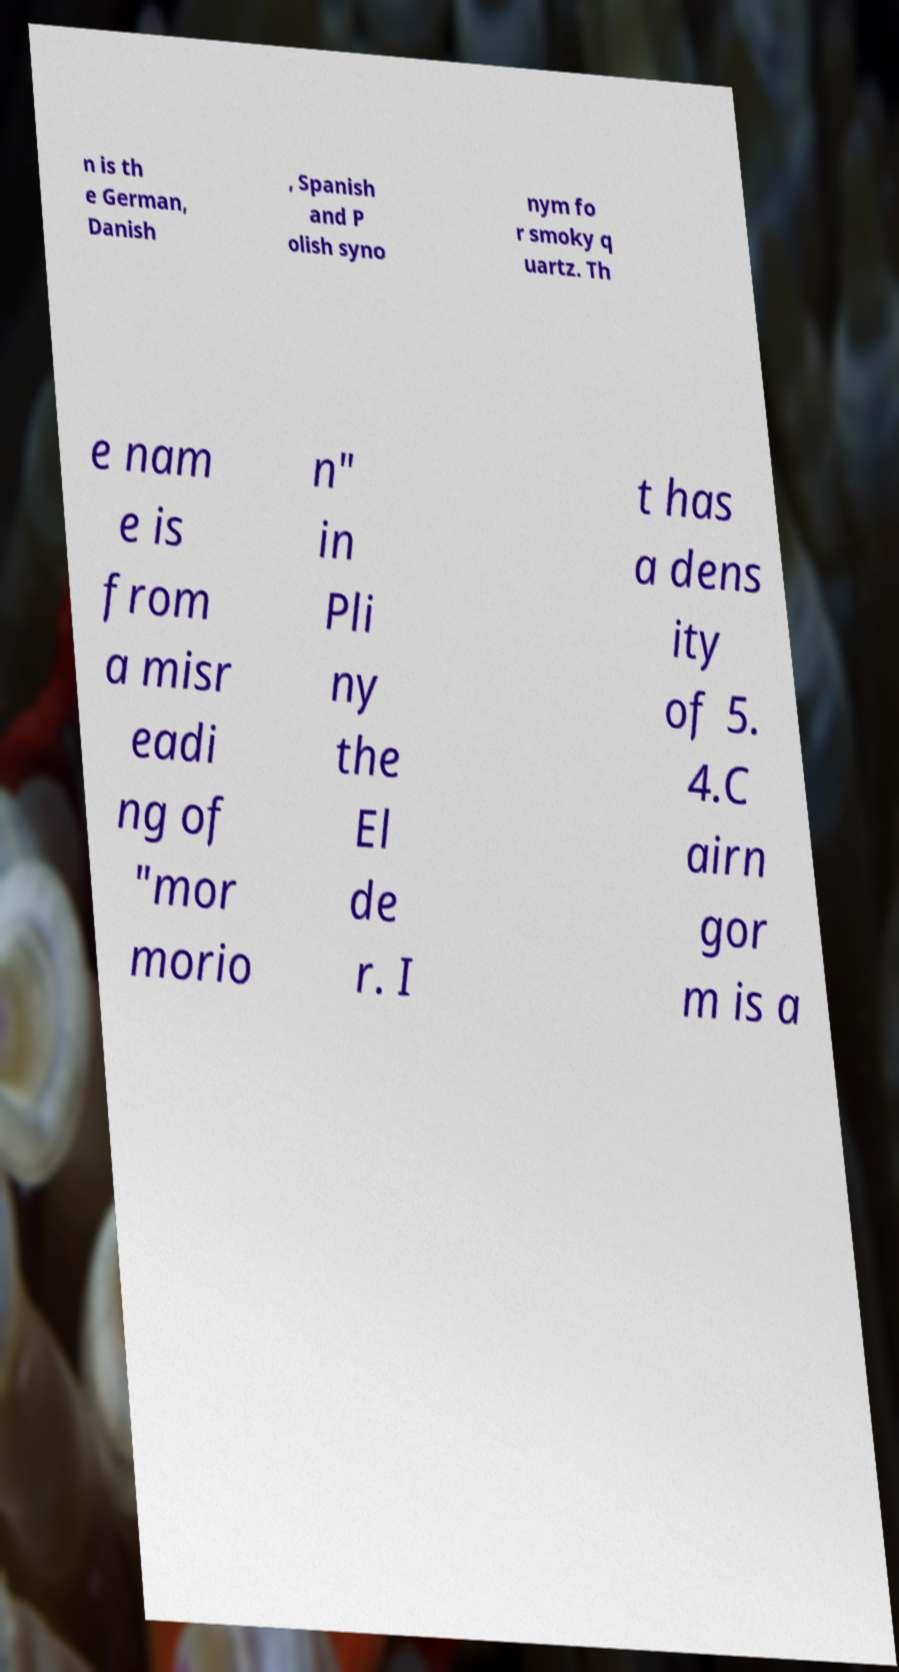Could you assist in decoding the text presented in this image and type it out clearly? n is th e German, Danish , Spanish and P olish syno nym fo r smoky q uartz. Th e nam e is from a misr eadi ng of "mor morio n" in Pli ny the El de r. I t has a dens ity of 5. 4.C airn gor m is a 